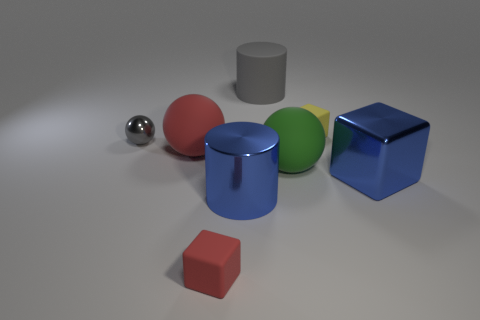Add 1 blue rubber cubes. How many objects exist? 9 Subtract all cylinders. How many objects are left? 6 Subtract 0 blue balls. How many objects are left? 8 Subtract all small yellow matte spheres. Subtract all big red matte spheres. How many objects are left? 7 Add 5 small rubber objects. How many small rubber objects are left? 7 Add 2 gray cylinders. How many gray cylinders exist? 3 